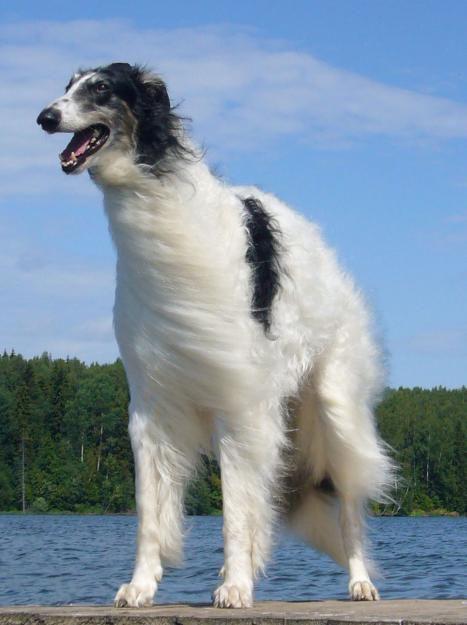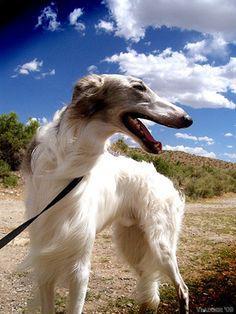The first image is the image on the left, the second image is the image on the right. Given the left and right images, does the statement "Two dogs are playing with each other in one image." hold true? Answer yes or no. No. 